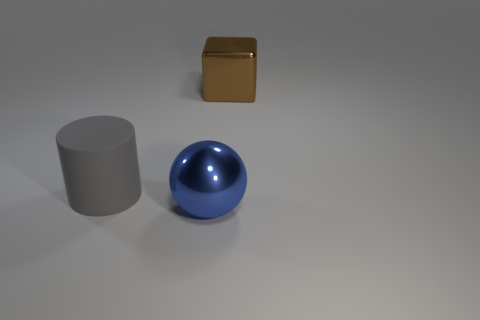Add 1 blue shiny spheres. How many objects exist? 4 Subtract all cylinders. How many objects are left? 2 Subtract 1 spheres. How many spheres are left? 0 Subtract all green cylinders. Subtract all red cubes. How many cylinders are left? 1 Subtract all small gray rubber balls. Subtract all blue things. How many objects are left? 2 Add 1 large blue spheres. How many large blue spheres are left? 2 Add 3 small cyan objects. How many small cyan objects exist? 3 Subtract 1 blue balls. How many objects are left? 2 